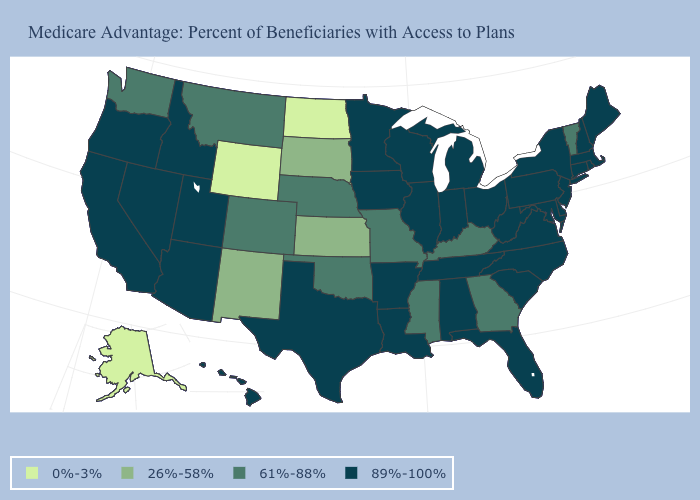Which states have the highest value in the USA?
Be succinct. California, Connecticut, Delaware, Florida, Hawaii, Iowa, Idaho, Illinois, Indiana, Louisiana, Massachusetts, Maryland, Maine, Michigan, Minnesota, North Carolina, New Hampshire, New Jersey, Nevada, New York, Ohio, Oregon, Pennsylvania, Rhode Island, South Carolina, Tennessee, Texas, Utah, Virginia, Wisconsin, West Virginia, Alabama, Arkansas, Arizona. What is the value of Virginia?
Quick response, please. 89%-100%. Does New York have a lower value than Alaska?
Short answer required. No. What is the value of Colorado?
Concise answer only. 61%-88%. Name the states that have a value in the range 89%-100%?
Give a very brief answer. California, Connecticut, Delaware, Florida, Hawaii, Iowa, Idaho, Illinois, Indiana, Louisiana, Massachusetts, Maryland, Maine, Michigan, Minnesota, North Carolina, New Hampshire, New Jersey, Nevada, New York, Ohio, Oregon, Pennsylvania, Rhode Island, South Carolina, Tennessee, Texas, Utah, Virginia, Wisconsin, West Virginia, Alabama, Arkansas, Arizona. What is the value of Massachusetts?
Keep it brief. 89%-100%. What is the value of Alabama?
Quick response, please. 89%-100%. What is the value of Kansas?
Be succinct. 26%-58%. What is the highest value in the USA?
Be succinct. 89%-100%. Name the states that have a value in the range 0%-3%?
Be succinct. North Dakota, Alaska, Wyoming. Name the states that have a value in the range 89%-100%?
Give a very brief answer. California, Connecticut, Delaware, Florida, Hawaii, Iowa, Idaho, Illinois, Indiana, Louisiana, Massachusetts, Maryland, Maine, Michigan, Minnesota, North Carolina, New Hampshire, New Jersey, Nevada, New York, Ohio, Oregon, Pennsylvania, Rhode Island, South Carolina, Tennessee, Texas, Utah, Virginia, Wisconsin, West Virginia, Alabama, Arkansas, Arizona. What is the value of Oklahoma?
Short answer required. 61%-88%. What is the value of Connecticut?
Answer briefly. 89%-100%. Which states have the lowest value in the South?
Short answer required. Georgia, Kentucky, Mississippi, Oklahoma. What is the value of Mississippi?
Write a very short answer. 61%-88%. 